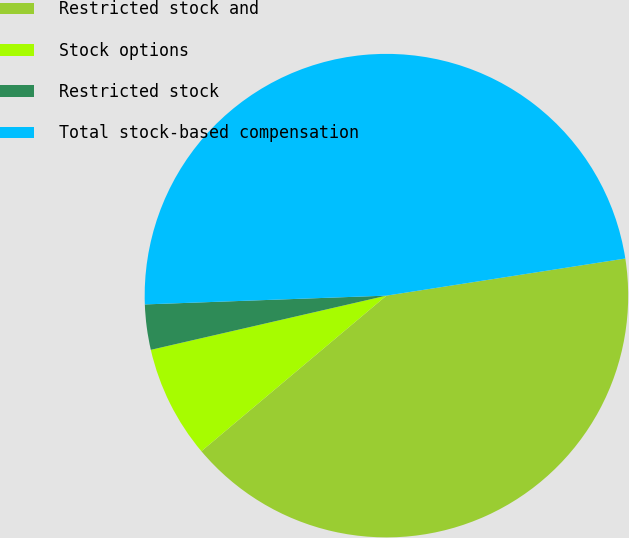Convert chart to OTSL. <chart><loc_0><loc_0><loc_500><loc_500><pie_chart><fcel>Restricted stock and<fcel>Stock options<fcel>Restricted stock<fcel>Total stock-based compensation<nl><fcel>41.33%<fcel>7.53%<fcel>3.02%<fcel>48.13%<nl></chart> 